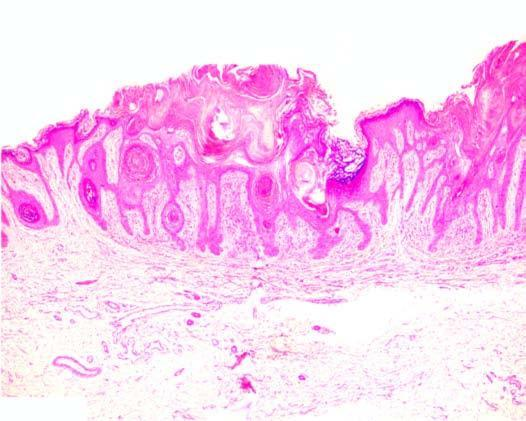s the border of the elevated lesion at the lateral margin in a straight line from the normal uninvolved epidermis?
Answer the question using a single word or phrase. Yes 